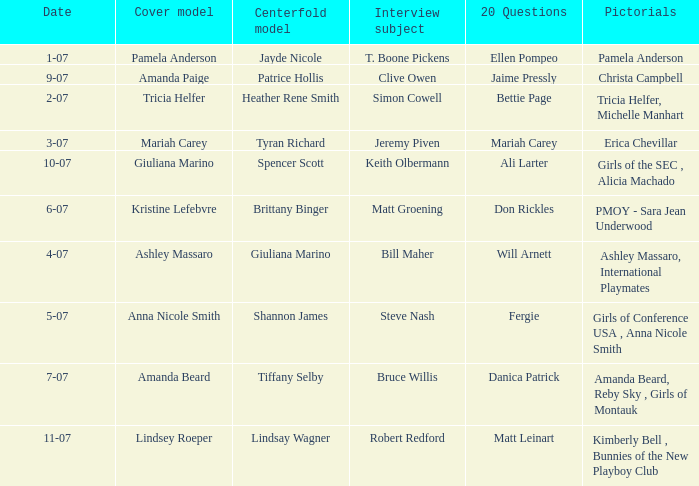Who was the centerfold model when the issue's pictorial was amanda beard, reby sky , girls of montauk ? Tiffany Selby. 